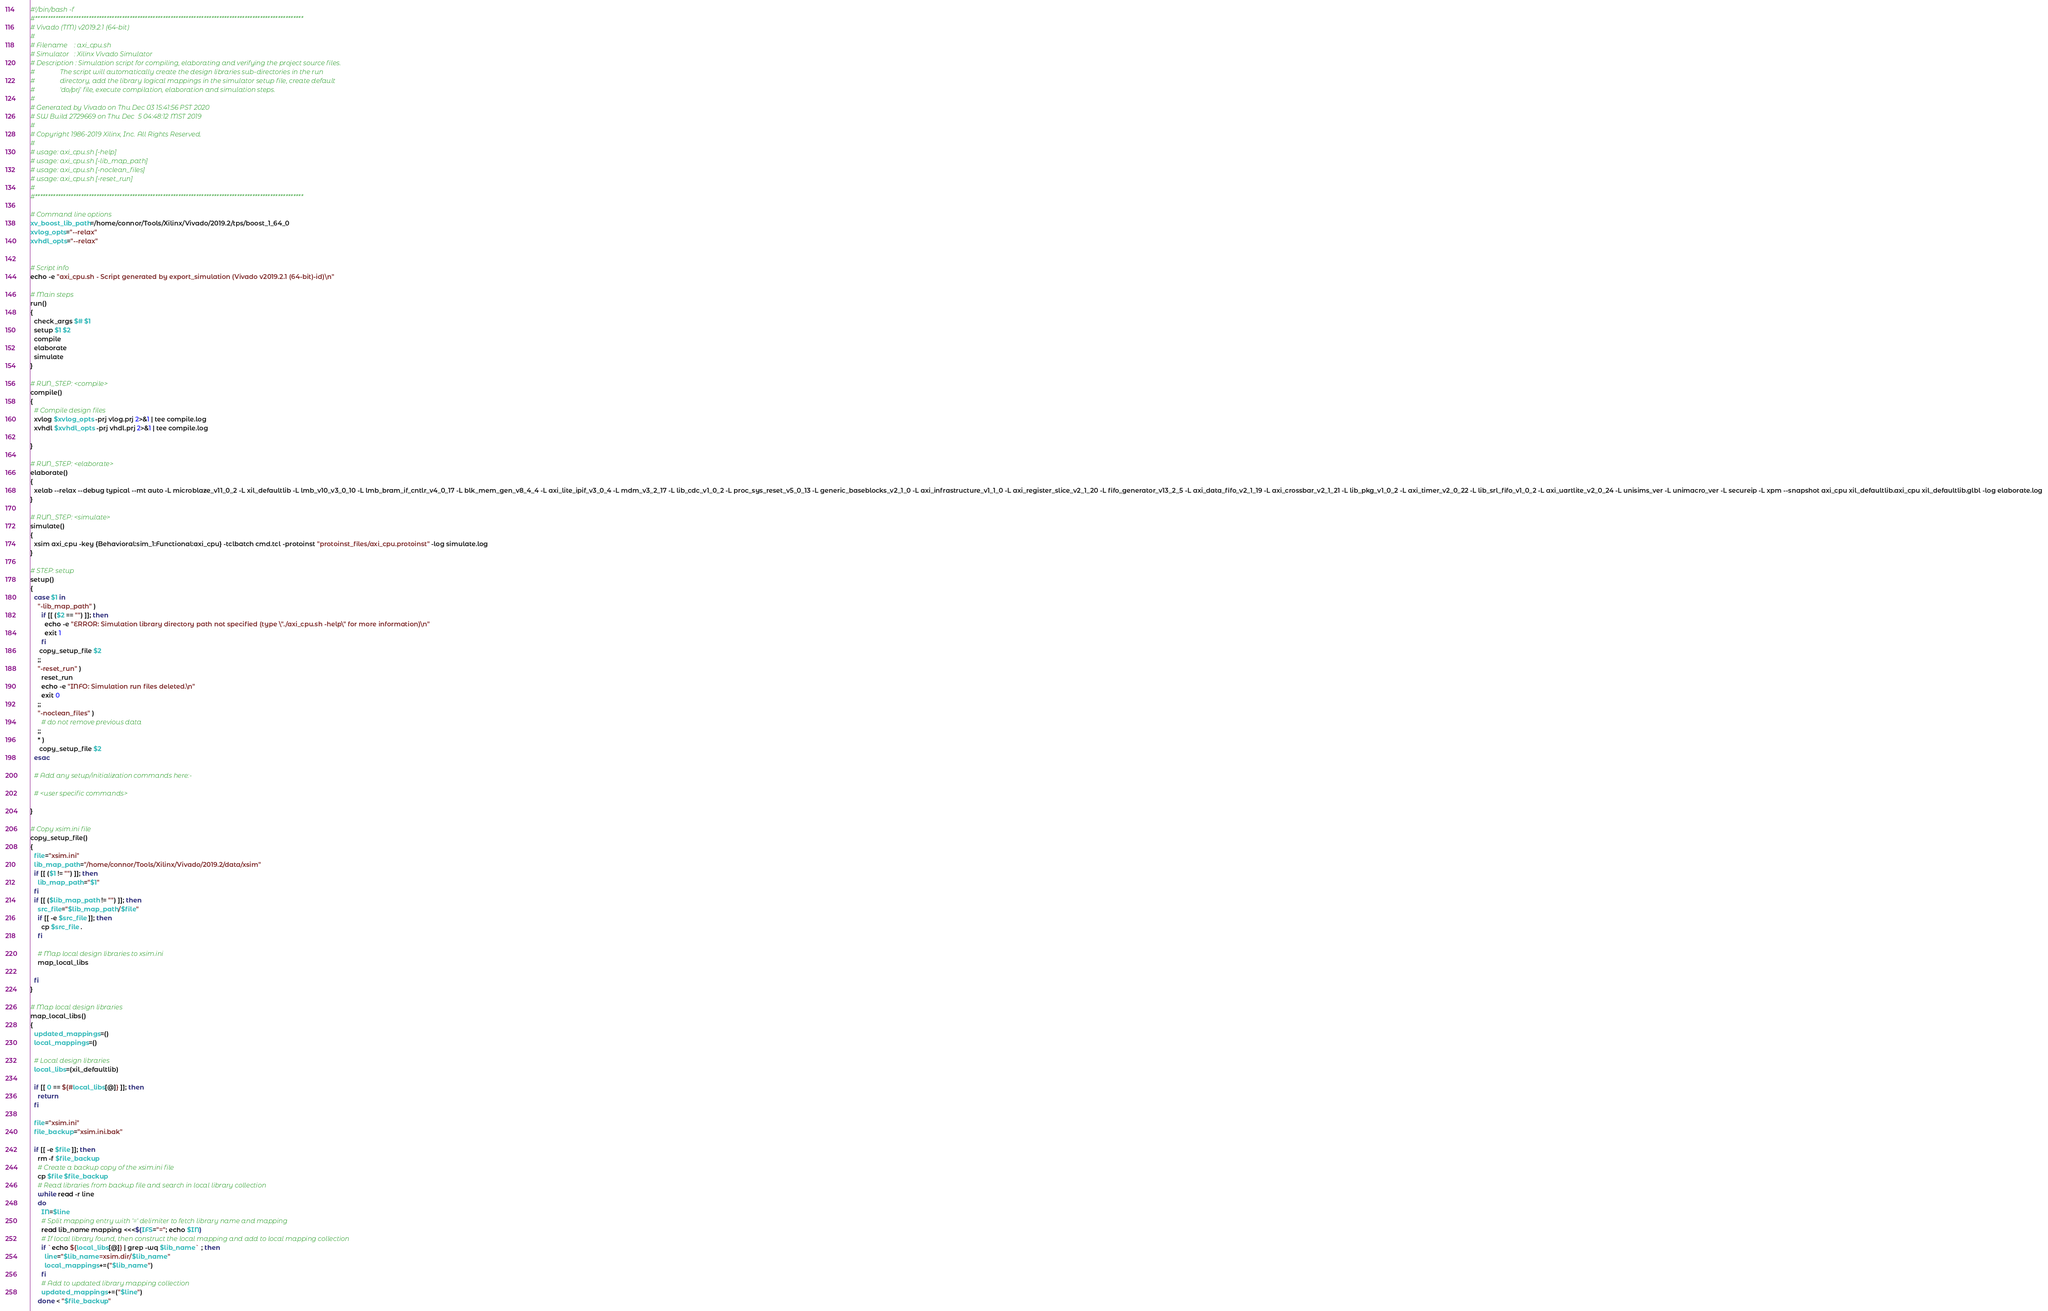<code> <loc_0><loc_0><loc_500><loc_500><_Bash_>#!/bin/bash -f
#*********************************************************************************************************
# Vivado (TM) v2019.2.1 (64-bit)
#
# Filename    : axi_cpu.sh
# Simulator   : Xilinx Vivado Simulator
# Description : Simulation script for compiling, elaborating and verifying the project source files.
#               The script will automatically create the design libraries sub-directories in the run
#               directory, add the library logical mappings in the simulator setup file, create default
#               'do/prj' file, execute compilation, elaboration and simulation steps.
#
# Generated by Vivado on Thu Dec 03 15:41:56 PST 2020
# SW Build 2729669 on Thu Dec  5 04:48:12 MST 2019
#
# Copyright 1986-2019 Xilinx, Inc. All Rights Reserved. 
#
# usage: axi_cpu.sh [-help]
# usage: axi_cpu.sh [-lib_map_path]
# usage: axi_cpu.sh [-noclean_files]
# usage: axi_cpu.sh [-reset_run]
#
#*********************************************************************************************************

# Command line options
xv_boost_lib_path=/home/connor/Tools/Xilinx/Vivado/2019.2/tps/boost_1_64_0
xvlog_opts="--relax"
xvhdl_opts="--relax"


# Script info
echo -e "axi_cpu.sh - Script generated by export_simulation (Vivado v2019.2.1 (64-bit)-id)\n"

# Main steps
run()
{
  check_args $# $1
  setup $1 $2
  compile
  elaborate
  simulate
}

# RUN_STEP: <compile>
compile()
{
  # Compile design files
  xvlog $xvlog_opts -prj vlog.prj 2>&1 | tee compile.log
  xvhdl $xvhdl_opts -prj vhdl.prj 2>&1 | tee compile.log

}

# RUN_STEP: <elaborate>
elaborate()
{
  xelab --relax --debug typical --mt auto -L microblaze_v11_0_2 -L xil_defaultlib -L lmb_v10_v3_0_10 -L lmb_bram_if_cntlr_v4_0_17 -L blk_mem_gen_v8_4_4 -L axi_lite_ipif_v3_0_4 -L mdm_v3_2_17 -L lib_cdc_v1_0_2 -L proc_sys_reset_v5_0_13 -L generic_baseblocks_v2_1_0 -L axi_infrastructure_v1_1_0 -L axi_register_slice_v2_1_20 -L fifo_generator_v13_2_5 -L axi_data_fifo_v2_1_19 -L axi_crossbar_v2_1_21 -L lib_pkg_v1_0_2 -L axi_timer_v2_0_22 -L lib_srl_fifo_v1_0_2 -L axi_uartlite_v2_0_24 -L unisims_ver -L unimacro_ver -L secureip -L xpm --snapshot axi_cpu xil_defaultlib.axi_cpu xil_defaultlib.glbl -log elaborate.log
}

# RUN_STEP: <simulate>
simulate()
{
  xsim axi_cpu -key {Behavioral:sim_1:Functional:axi_cpu} -tclbatch cmd.tcl -protoinst "protoinst_files/axi_cpu.protoinst" -log simulate.log
}

# STEP: setup
setup()
{
  case $1 in
    "-lib_map_path" )
      if [[ ($2 == "") ]]; then
        echo -e "ERROR: Simulation library directory path not specified (type \"./axi_cpu.sh -help\" for more information)\n"
        exit 1
      fi
     copy_setup_file $2
    ;;
    "-reset_run" )
      reset_run
      echo -e "INFO: Simulation run files deleted.\n"
      exit 0
    ;;
    "-noclean_files" )
      # do not remove previous data
    ;;
    * )
     copy_setup_file $2
  esac

  # Add any setup/initialization commands here:-

  # <user specific commands>

}

# Copy xsim.ini file
copy_setup_file()
{
  file="xsim.ini"
  lib_map_path="/home/connor/Tools/Xilinx/Vivado/2019.2/data/xsim"
  if [[ ($1 != "") ]]; then
    lib_map_path="$1"
  fi
  if [[ ($lib_map_path != "") ]]; then
    src_file="$lib_map_path/$file"
    if [[ -e $src_file ]]; then
      cp $src_file .
    fi

    # Map local design libraries to xsim.ini
    map_local_libs

  fi
}

# Map local design libraries
map_local_libs()
{
  updated_mappings=()
  local_mappings=()

  # Local design libraries
  local_libs=(xil_defaultlib)

  if [[ 0 == ${#local_libs[@]} ]]; then
    return
  fi

  file="xsim.ini"
  file_backup="xsim.ini.bak"

  if [[ -e $file ]]; then
    rm -f $file_backup
    # Create a backup copy of the xsim.ini file
    cp $file $file_backup
    # Read libraries from backup file and search in local library collection
    while read -r line
    do
      IN=$line
      # Split mapping entry with '=' delimiter to fetch library name and mapping
      read lib_name mapping <<<$(IFS="="; echo $IN)
      # If local library found, then construct the local mapping and add to local mapping collection
      if `echo ${local_libs[@]} | grep -wq $lib_name` ; then
        line="$lib_name=xsim.dir/$lib_name"
        local_mappings+=("$lib_name")
      fi
      # Add to updated library mapping collection
      updated_mappings+=("$line")
    done < "$file_backup"</code> 